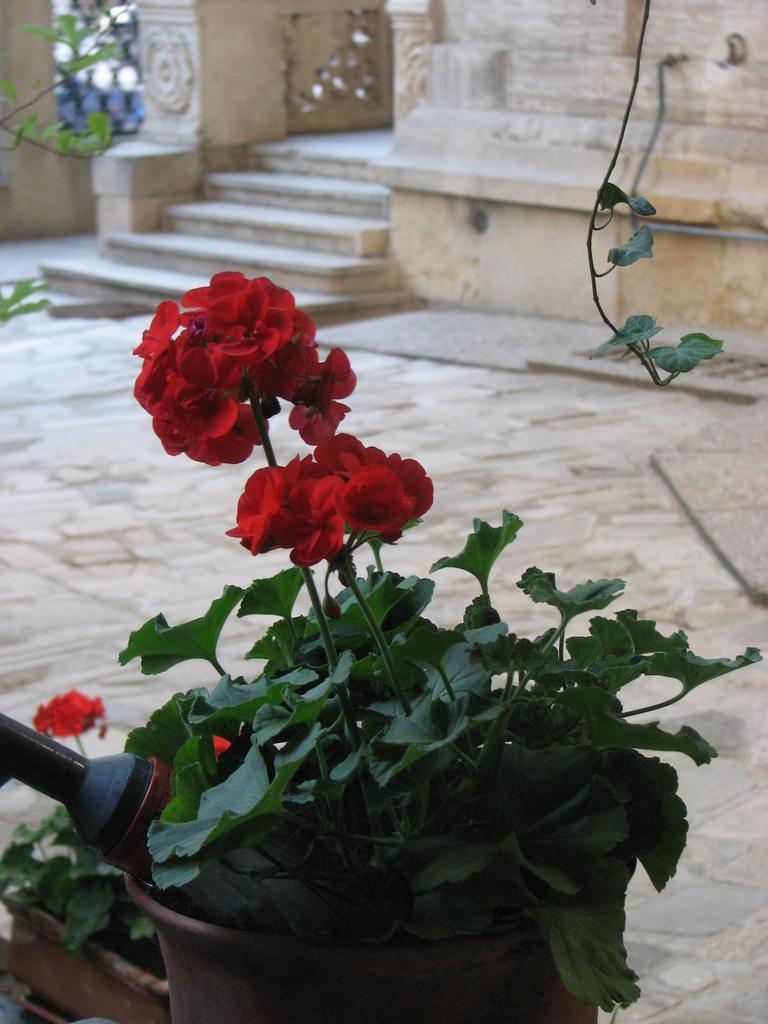How would you summarize this image in a sentence or two? In this image I can see few flowers which are red in color to plants which are green in color. I can see a black colored object and in the background I can see the floor, few stairs and a building. 